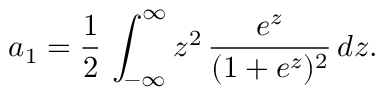Convert formula to latex. <formula><loc_0><loc_0><loc_500><loc_500>a _ { 1 } = \frac { 1 } { 2 } \, \int _ { - \infty } ^ { \infty } z ^ { 2 } \, \frac { e ^ { z } } { ( 1 + e ^ { z } ) ^ { 2 } } \, d z .</formula> 